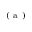Convert formula to latex. <formula><loc_0><loc_0><loc_500><loc_500>^ { ( } a )</formula> 